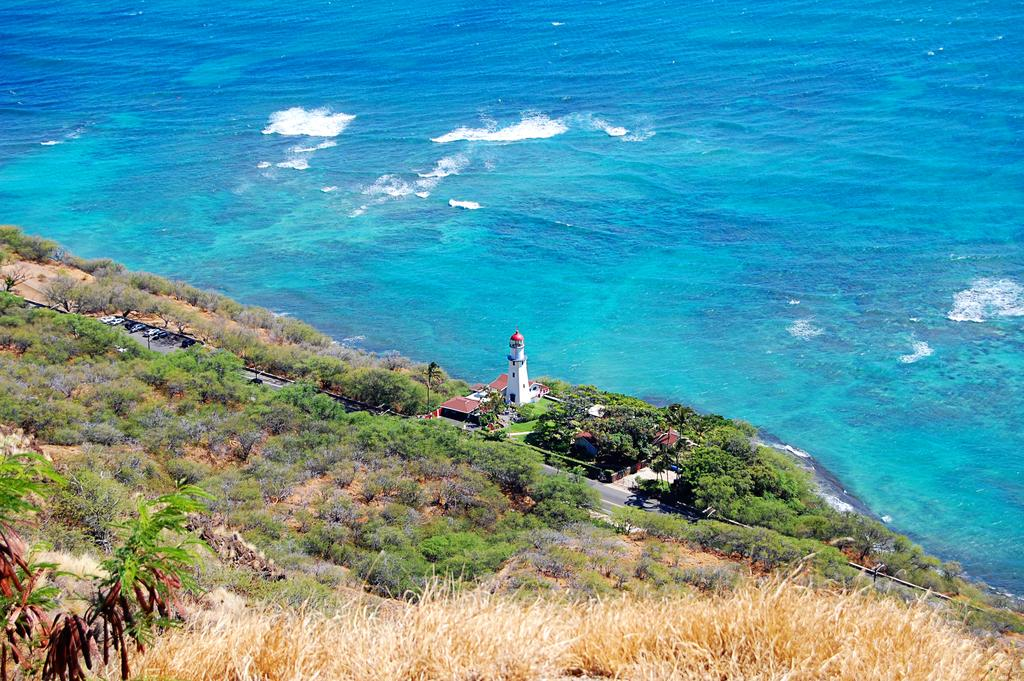What type of natural elements can be seen in the image? There are trees and plants in the image. What type of man-made structure is present in the image? There is a road in the image, and buildings are located near the road. What type of water feature can be seen in the image? There is water visible in the image. What tall structure is present in the image? There is a tower in the image. What type of whistle can be heard coming from the tower in the image? There is no whistle present in the image, and no sound can be heard from the tower. 